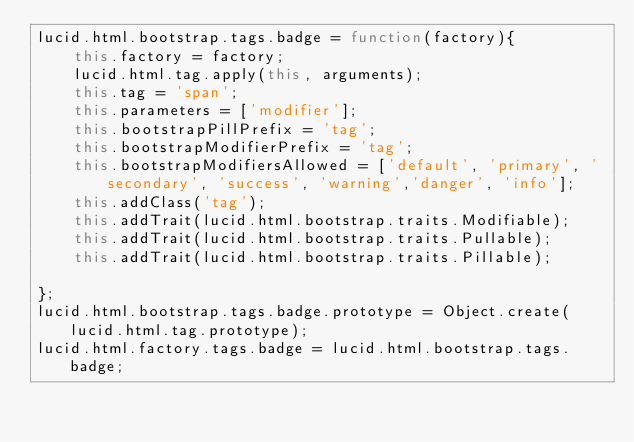Convert code to text. <code><loc_0><loc_0><loc_500><loc_500><_JavaScript_>lucid.html.bootstrap.tags.badge = function(factory){
	this.factory = factory;
	lucid.html.tag.apply(this, arguments);
	this.tag = 'span';
	this.parameters = ['modifier'];
	this.bootstrapPillPrefix = 'tag';
	this.bootstrapModifierPrefix = 'tag';
	this.bootstrapModifiersAllowed = ['default', 'primary', 'secondary', 'success', 'warning','danger', 'info'];
	this.addClass('tag');
	this.addTrait(lucid.html.bootstrap.traits.Modifiable);
	this.addTrait(lucid.html.bootstrap.traits.Pullable);
	this.addTrait(lucid.html.bootstrap.traits.Pillable);

};
lucid.html.bootstrap.tags.badge.prototype = Object.create(lucid.html.tag.prototype);
lucid.html.factory.tags.badge = lucid.html.bootstrap.tags.badge;
</code> 